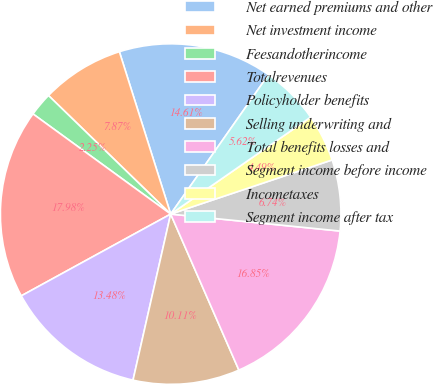Convert chart to OTSL. <chart><loc_0><loc_0><loc_500><loc_500><pie_chart><fcel>Net earned premiums and other<fcel>Net investment income<fcel>Feesandotherincome<fcel>Totalrevenues<fcel>Policyholder benefits<fcel>Selling underwriting and<fcel>Total benefits losses and<fcel>Segment income before income<fcel>Incometaxes<fcel>Segment income after tax<nl><fcel>14.61%<fcel>7.87%<fcel>2.25%<fcel>17.98%<fcel>13.48%<fcel>10.11%<fcel>16.85%<fcel>6.74%<fcel>4.49%<fcel>5.62%<nl></chart> 